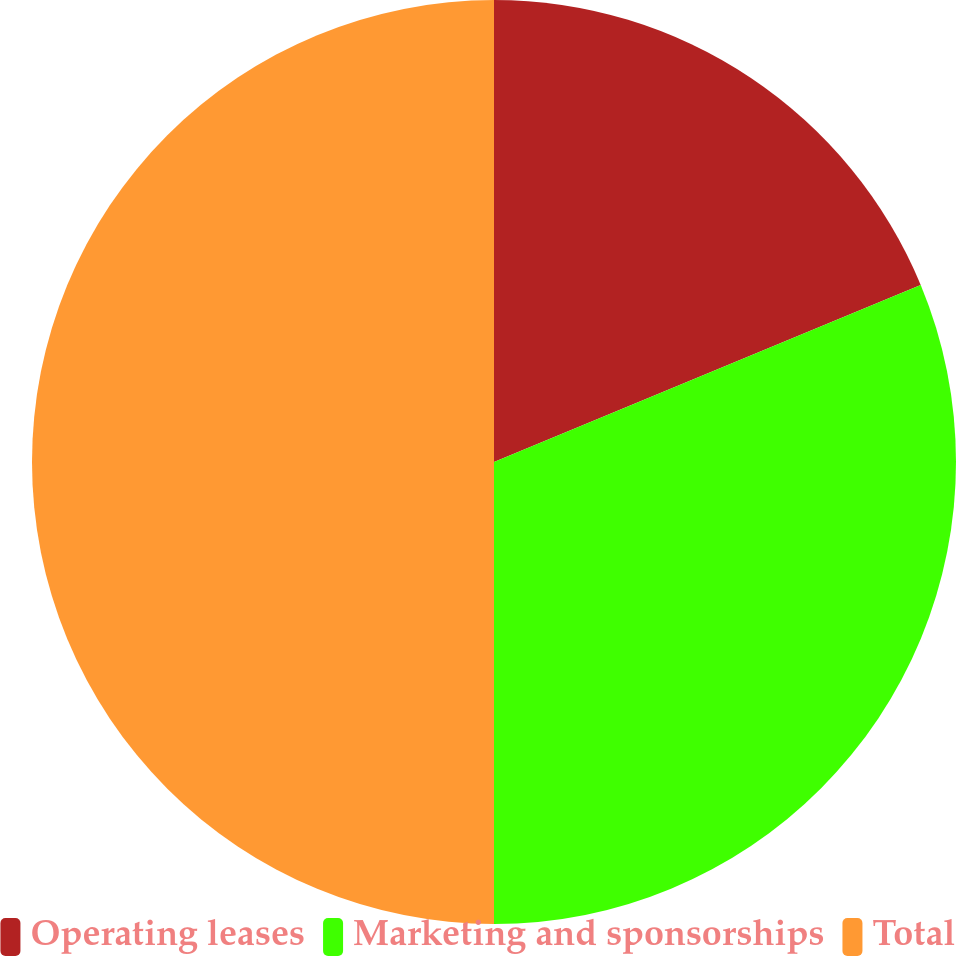Convert chart to OTSL. <chart><loc_0><loc_0><loc_500><loc_500><pie_chart><fcel>Operating leases<fcel>Marketing and sponsorships<fcel>Total<nl><fcel>18.74%<fcel>31.26%<fcel>50.0%<nl></chart> 